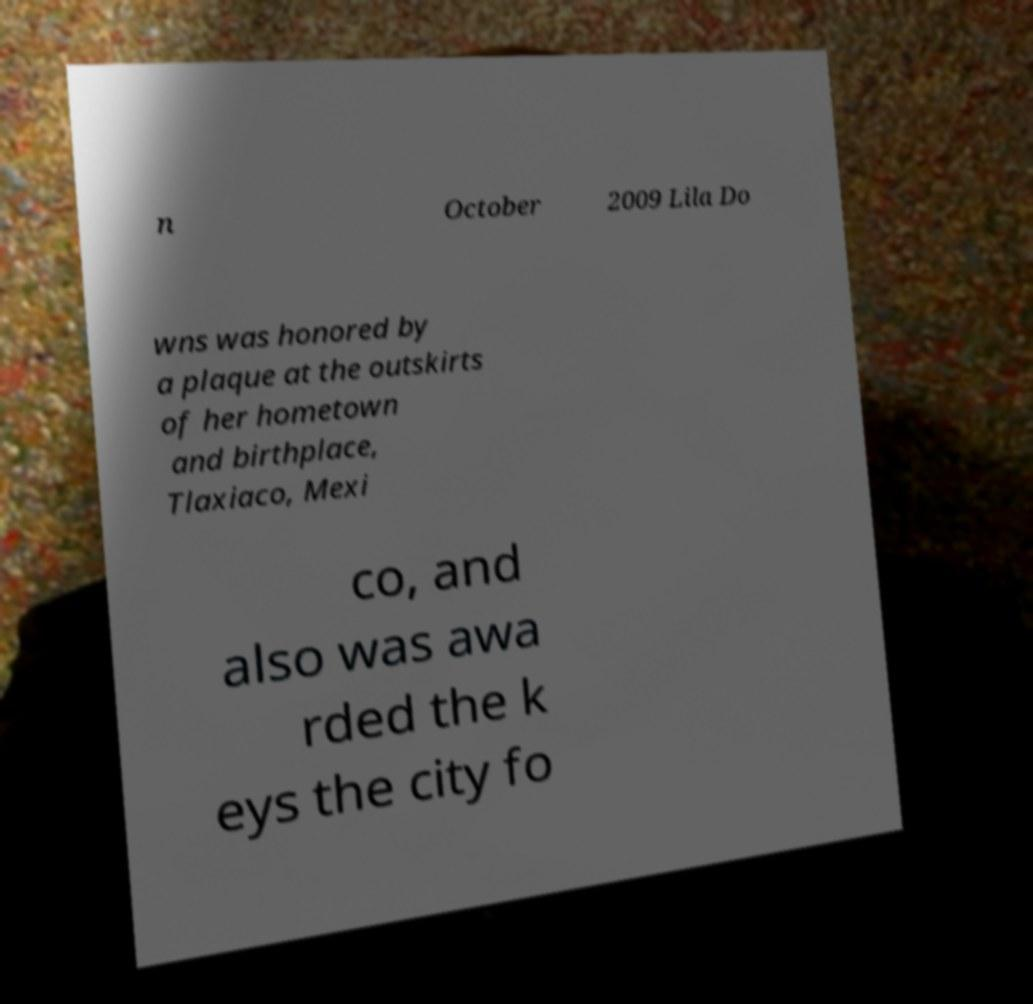For documentation purposes, I need the text within this image transcribed. Could you provide that? n October 2009 Lila Do wns was honored by a plaque at the outskirts of her hometown and birthplace, Tlaxiaco, Mexi co, and also was awa rded the k eys the city fo 